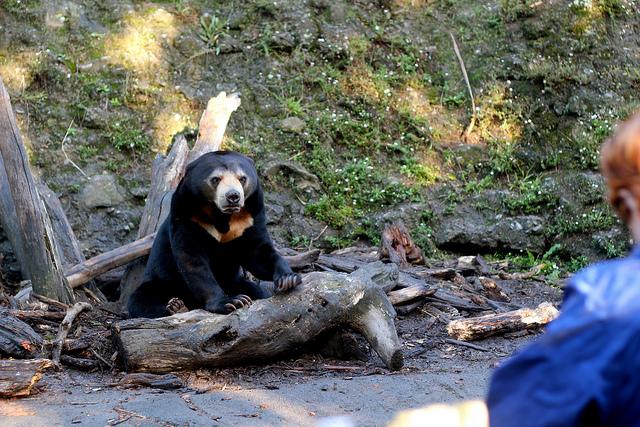What animal is shown?
Quick response, please. Bear. Is the bear angry?
Keep it brief. No. Where do you think this scene took place?
Write a very short answer. Zoo. What type of bear is in view?
Answer briefly. Black. 